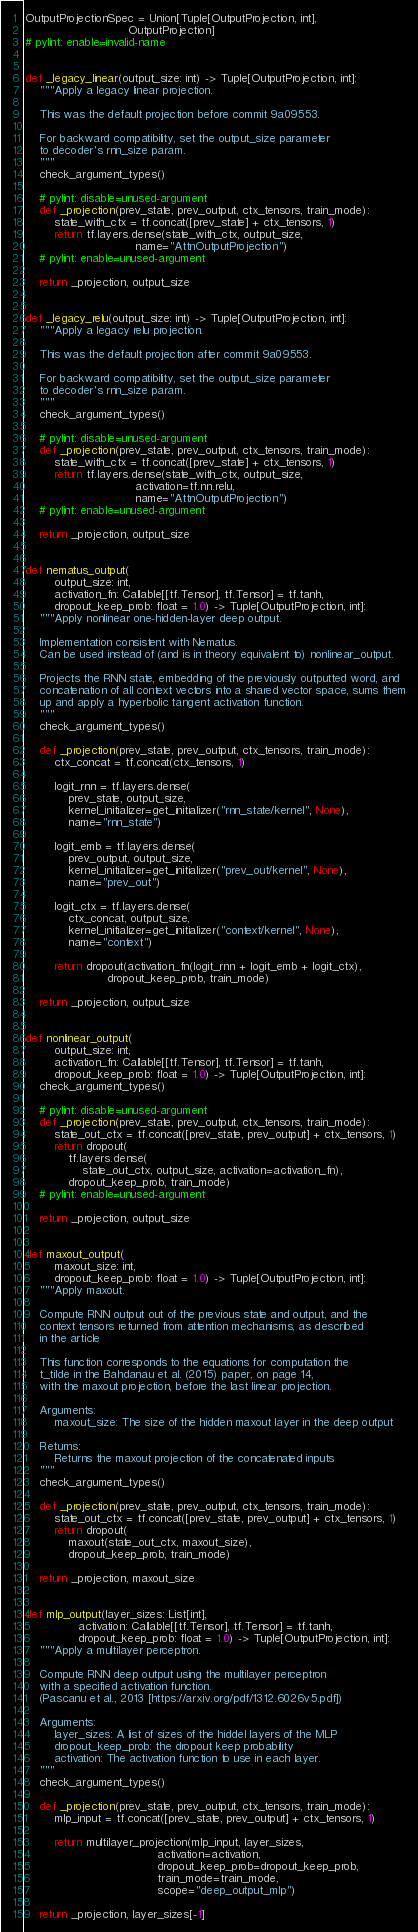Convert code to text. <code><loc_0><loc_0><loc_500><loc_500><_Python_>OutputProjectionSpec = Union[Tuple[OutputProjection, int],
                             OutputProjection]
# pylint: enable=invalid-name


def _legacy_linear(output_size: int) -> Tuple[OutputProjection, int]:
    """Apply a legacy linear projection.

    This was the default projection before commit 9a09553.

    For backward compatibility, set the output_size parameter
    to decoder's rnn_size param.
    """
    check_argument_types()

    # pylint: disable=unused-argument
    def _projection(prev_state, prev_output, ctx_tensors, train_mode):
        state_with_ctx = tf.concat([prev_state] + ctx_tensors, 1)
        return tf.layers.dense(state_with_ctx, output_size,
                               name="AttnOutputProjection")
    # pylint: enable=unused-argument

    return _projection, output_size


def _legacy_relu(output_size: int) -> Tuple[OutputProjection, int]:
    """Apply a legacy relu projection.

    This was the default projection after commit 9a09553.

    For backward compatibility, set the output_size parameter
    to decoder's rnn_size param.
    """
    check_argument_types()

    # pylint: disable=unused-argument
    def _projection(prev_state, prev_output, ctx_tensors, train_mode):
        state_with_ctx = tf.concat([prev_state] + ctx_tensors, 1)
        return tf.layers.dense(state_with_ctx, output_size,
                               activation=tf.nn.relu,
                               name="AttnOutputProjection")
    # pylint: enable=unused-argument

    return _projection, output_size


def nematus_output(
        output_size: int,
        activation_fn: Callable[[tf.Tensor], tf.Tensor] = tf.tanh,
        dropout_keep_prob: float = 1.0) -> Tuple[OutputProjection, int]:
    """Apply nonlinear one-hidden-layer deep output.

    Implementation consistent with Nematus.
    Can be used instead of (and is in theory equivalent to) nonlinear_output.

    Projects the RNN state, embedding of the previously outputted word, and
    concatenation of all context vectors into a shared vector space, sums them
    up and apply a hyperbolic tangent activation function.
    """
    check_argument_types()

    def _projection(prev_state, prev_output, ctx_tensors, train_mode):
        ctx_concat = tf.concat(ctx_tensors, 1)

        logit_rnn = tf.layers.dense(
            prev_state, output_size,
            kernel_initializer=get_initializer("rnn_state/kernel", None),
            name="rnn_state")

        logit_emb = tf.layers.dense(
            prev_output, output_size,
            kernel_initializer=get_initializer("prev_out/kernel", None),
            name="prev_out")

        logit_ctx = tf.layers.dense(
            ctx_concat, output_size,
            kernel_initializer=get_initializer("context/kernel", None),
            name="context")

        return dropout(activation_fn(logit_rnn + logit_emb + logit_ctx),
                       dropout_keep_prob, train_mode)

    return _projection, output_size


def nonlinear_output(
        output_size: int,
        activation_fn: Callable[[tf.Tensor], tf.Tensor] = tf.tanh,
        dropout_keep_prob: float = 1.0) -> Tuple[OutputProjection, int]:
    check_argument_types()

    # pylint: disable=unused-argument
    def _projection(prev_state, prev_output, ctx_tensors, train_mode):
        state_out_ctx = tf.concat([prev_state, prev_output] + ctx_tensors, 1)
        return dropout(
            tf.layers.dense(
                state_out_ctx, output_size, activation=activation_fn),
            dropout_keep_prob, train_mode)
    # pylint: enable=unused-argument

    return _projection, output_size


def maxout_output(
        maxout_size: int,
        dropout_keep_prob: float = 1.0) -> Tuple[OutputProjection, int]:
    """Apply maxout.

    Compute RNN output out of the previous state and output, and the
    context tensors returned from attention mechanisms, as described
    in the article

    This function corresponds to the equations for computation the
    t_tilde in the Bahdanau et al. (2015) paper, on page 14,
    with the maxout projection, before the last linear projection.

    Arguments:
        maxout_size: The size of the hidden maxout layer in the deep output

    Returns:
        Returns the maxout projection of the concatenated inputs
    """
    check_argument_types()

    def _projection(prev_state, prev_output, ctx_tensors, train_mode):
        state_out_ctx = tf.concat([prev_state, prev_output] + ctx_tensors, 1)
        return dropout(
            maxout(state_out_ctx, maxout_size),
            dropout_keep_prob, train_mode)

    return _projection, maxout_size


def mlp_output(layer_sizes: List[int],
               activation: Callable[[tf.Tensor], tf.Tensor] = tf.tanh,
               dropout_keep_prob: float = 1.0) -> Tuple[OutputProjection, int]:
    """Apply a multilayer perceptron.

    Compute RNN deep output using the multilayer perceptron
    with a specified activation function.
    (Pascanu et al., 2013 [https://arxiv.org/pdf/1312.6026v5.pdf])

    Arguments:
        layer_sizes: A list of sizes of the hiddel layers of the MLP
        dropout_keep_prob: the dropout keep probability
        activation: The activation function to use in each layer.
    """
    check_argument_types()

    def _projection(prev_state, prev_output, ctx_tensors, train_mode):
        mlp_input = tf.concat([prev_state, prev_output] + ctx_tensors, 1)

        return multilayer_projection(mlp_input, layer_sizes,
                                     activation=activation,
                                     dropout_keep_prob=dropout_keep_prob,
                                     train_mode=train_mode,
                                     scope="deep_output_mlp")

    return _projection, layer_sizes[-1]
</code> 